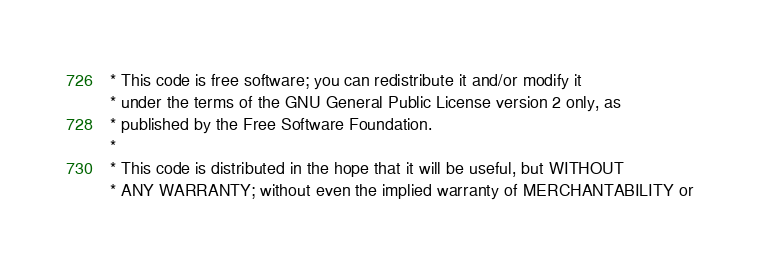Convert code to text. <code><loc_0><loc_0><loc_500><loc_500><_Java_> * This code is free software; you can redistribute it and/or modify it
 * under the terms of the GNU General Public License version 2 only, as
 * published by the Free Software Foundation.
 *
 * This code is distributed in the hope that it will be useful, but WITHOUT
 * ANY WARRANTY; without even the implied warranty of MERCHANTABILITY or</code> 